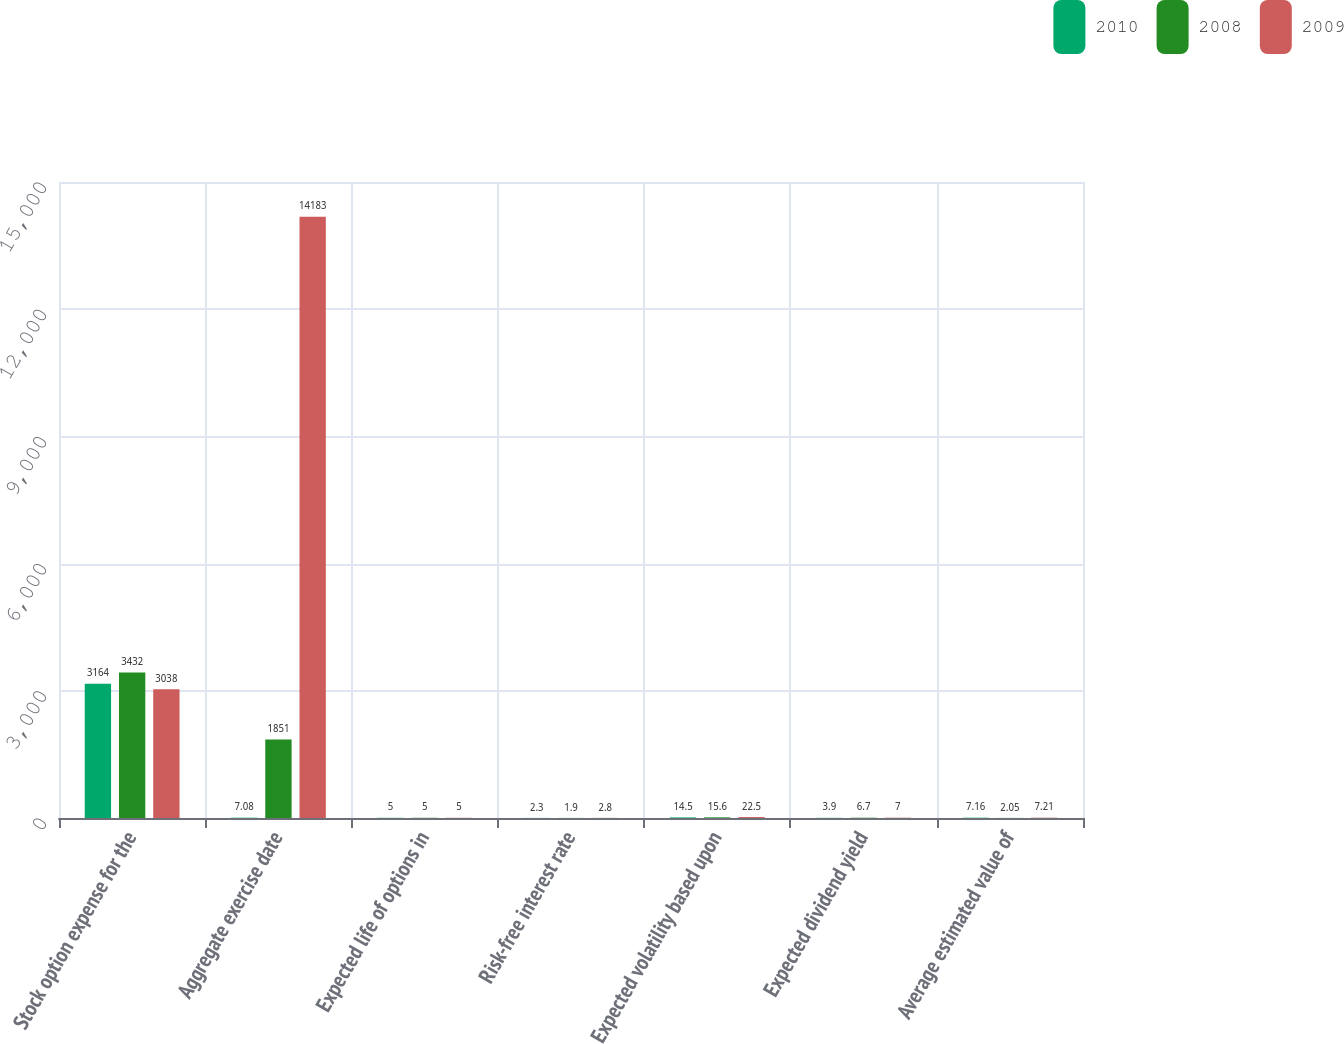Convert chart. <chart><loc_0><loc_0><loc_500><loc_500><stacked_bar_chart><ecel><fcel>Stock option expense for the<fcel>Aggregate exercise date<fcel>Expected life of options in<fcel>Risk-free interest rate<fcel>Expected volatility based upon<fcel>Expected dividend yield<fcel>Average estimated value of<nl><fcel>2010<fcel>3164<fcel>7.08<fcel>5<fcel>2.3<fcel>14.5<fcel>3.9<fcel>7.16<nl><fcel>2008<fcel>3432<fcel>1851<fcel>5<fcel>1.9<fcel>15.6<fcel>6.7<fcel>2.05<nl><fcel>2009<fcel>3038<fcel>14183<fcel>5<fcel>2.8<fcel>22.5<fcel>7<fcel>7.21<nl></chart> 